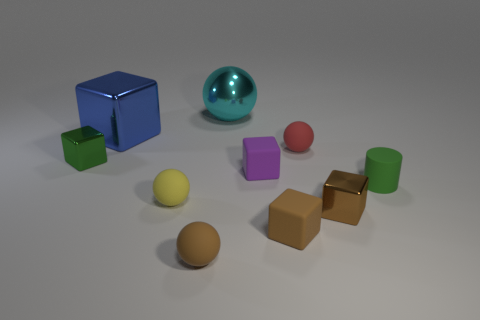What is the small object that is behind the tiny purple cube and right of the brown rubber block made of?
Make the answer very short. Rubber. There is a green metallic thing; is its shape the same as the big shiny object in front of the large sphere?
Keep it short and to the point. Yes. How many other things are the same size as the rubber cylinder?
Make the answer very short. 7. Are there more brown blocks than yellow things?
Provide a succinct answer. Yes. How many metallic objects are on the left side of the large cyan ball and behind the tiny green metal cube?
Make the answer very short. 1. There is a metal thing that is in front of the green thing that is in front of the small green metal object in front of the tiny red matte ball; what shape is it?
Offer a very short reply. Cube. Are there any other things that are the same shape as the small yellow object?
Your answer should be very brief. Yes. How many blocks are red matte objects or tiny brown rubber things?
Ensure brevity in your answer.  1. There is a small metallic cube left of the tiny brown rubber ball; does it have the same color as the tiny matte cylinder?
Give a very brief answer. Yes. The tiny green thing that is to the left of the small green thing that is right of the brown metallic block that is to the right of the metallic ball is made of what material?
Provide a succinct answer. Metal. 